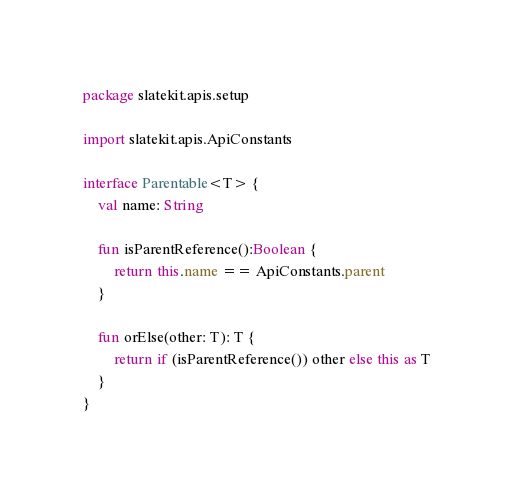<code> <loc_0><loc_0><loc_500><loc_500><_Kotlin_>package slatekit.apis.setup

import slatekit.apis.ApiConstants

interface Parentable<T> {
    val name: String

    fun isParentReference():Boolean {
        return this.name == ApiConstants.parent
    }

    fun orElse(other: T): T {
        return if (isParentReference()) other else this as T
    }
}
</code> 